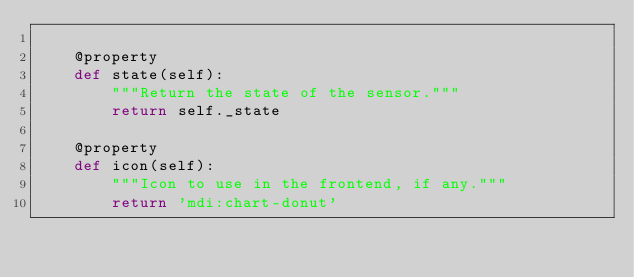Convert code to text. <code><loc_0><loc_0><loc_500><loc_500><_Python_>
    @property
    def state(self):
        """Return the state of the sensor."""
        return self._state

    @property
    def icon(self):
        """Icon to use in the frontend, if any."""
        return 'mdi:chart-donut'
</code> 